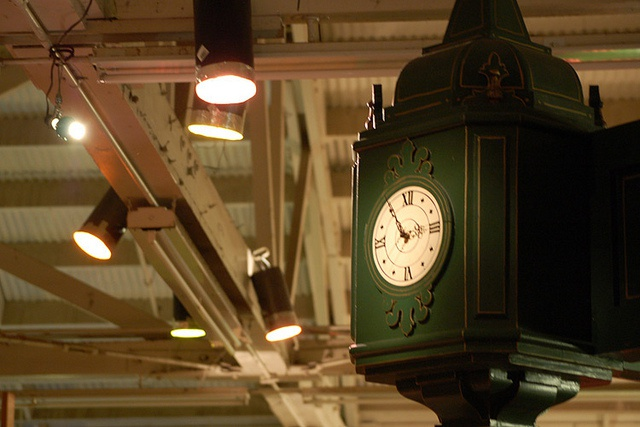Describe the objects in this image and their specific colors. I can see a clock in maroon, khaki, tan, and lightyellow tones in this image. 